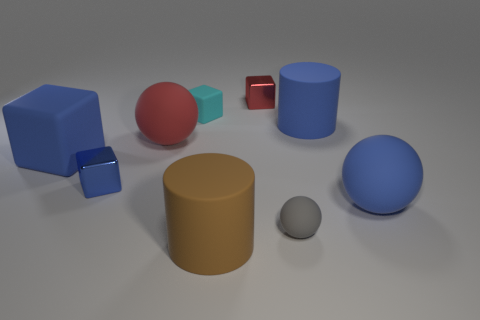Are any large blue rubber objects visible?
Give a very brief answer. Yes. What number of small blue shiny blocks are left of the rubber cylinder that is behind the small metallic object in front of the red block?
Provide a short and direct response. 1. There is a small blue thing; does it have the same shape as the red matte object behind the big rubber cube?
Your response must be concise. No. Is the number of large cyan matte cubes greater than the number of small blue metallic blocks?
Make the answer very short. No. Is there any other thing that is the same size as the blue sphere?
Your response must be concise. Yes. Do the blue thing that is behind the blue rubber block and the small gray thing have the same shape?
Make the answer very short. No. Are there more large rubber blocks that are left of the large red object than small yellow metallic cubes?
Provide a short and direct response. Yes. What color is the big matte cylinder behind the blue matte object to the left of the tiny sphere?
Give a very brief answer. Blue. How many red objects are there?
Offer a terse response. 2. How many rubber things are to the right of the large blue rubber cylinder and in front of the small gray rubber object?
Provide a succinct answer. 0. 